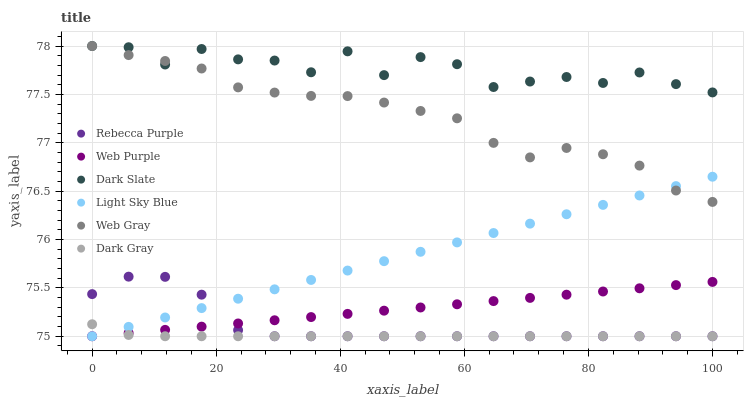Does Dark Gray have the minimum area under the curve?
Answer yes or no. Yes. Does Dark Slate have the maximum area under the curve?
Answer yes or no. Yes. Does Dark Slate have the minimum area under the curve?
Answer yes or no. No. Does Dark Gray have the maximum area under the curve?
Answer yes or no. No. Is Light Sky Blue the smoothest?
Answer yes or no. Yes. Is Dark Slate the roughest?
Answer yes or no. Yes. Is Dark Gray the smoothest?
Answer yes or no. No. Is Dark Gray the roughest?
Answer yes or no. No. Does Dark Gray have the lowest value?
Answer yes or no. Yes. Does Dark Slate have the lowest value?
Answer yes or no. No. Does Dark Slate have the highest value?
Answer yes or no. Yes. Does Dark Gray have the highest value?
Answer yes or no. No. Is Web Purple less than Dark Slate?
Answer yes or no. Yes. Is Web Gray greater than Dark Gray?
Answer yes or no. Yes. Does Rebecca Purple intersect Web Purple?
Answer yes or no. Yes. Is Rebecca Purple less than Web Purple?
Answer yes or no. No. Is Rebecca Purple greater than Web Purple?
Answer yes or no. No. Does Web Purple intersect Dark Slate?
Answer yes or no. No. 